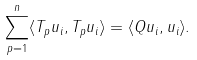Convert formula to latex. <formula><loc_0><loc_0><loc_500><loc_500>\sum _ { p = 1 } ^ { n } \langle T _ { p } u _ { i } , T _ { p } u _ { i } \rangle = \langle Q u _ { i } , u _ { i } \rangle .</formula> 